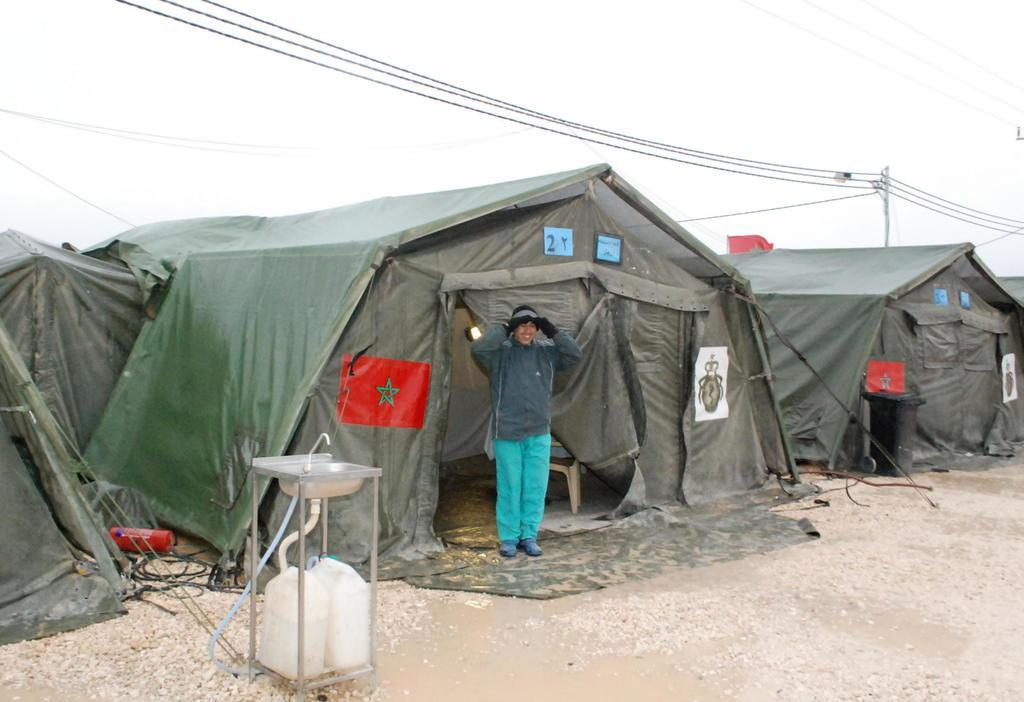Describe this image in one or two sentences. Here is a person standing. These are the tents. I think this looks like a frame, which is attached to the tents. I can see a wash basin with a tap and a pipe are attached to the can´s. This looks like a current pole with the current wires. 